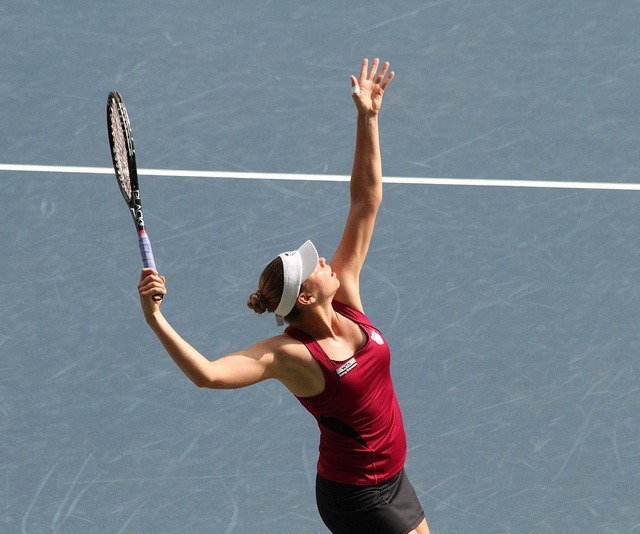Describe the objects in this image and their specific colors. I can see people in gray, black, maroon, and brown tones and tennis racket in gray, black, darkgray, and lightgray tones in this image. 